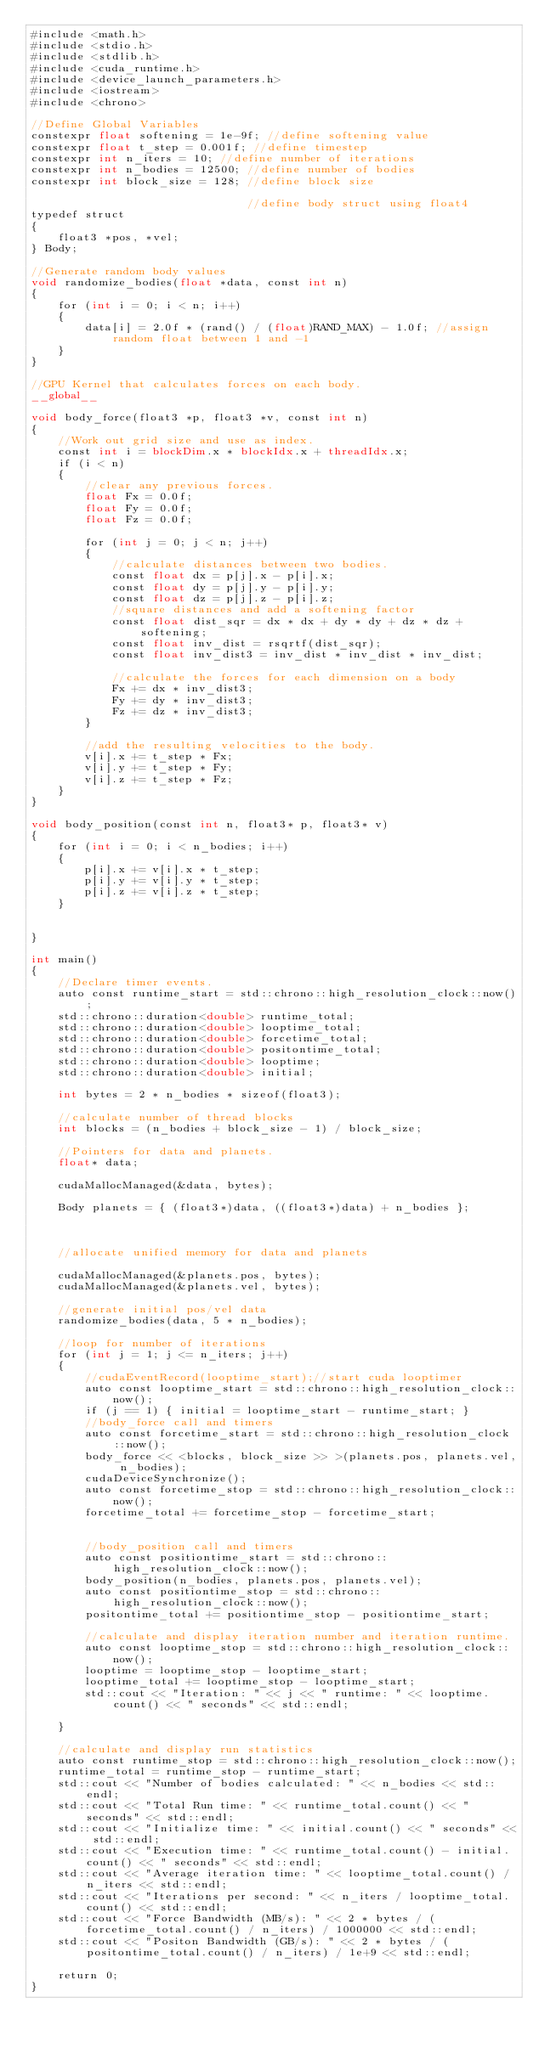Convert code to text. <code><loc_0><loc_0><loc_500><loc_500><_Cuda_>#include <math.h>
#include <stdio.h>
#include <stdlib.h>
#include <cuda_runtime.h>
#include <device_launch_parameters.h>
#include <iostream>
#include <chrono>

//Define Global Variables
constexpr float softening = 1e-9f; //define softening value
constexpr float t_step = 0.001f; //define timestep
constexpr int n_iters = 10; //define number of iterations
constexpr int n_bodies = 12500; //define number of bodies
constexpr int block_size = 128; //define block size

								//define body struct using float4
typedef struct
{
	float3 *pos, *vel;
} Body;

//Generate random body values
void randomize_bodies(float *data, const int n)
{
	for (int i = 0; i < n; i++)
	{
		data[i] = 2.0f * (rand() / (float)RAND_MAX) - 1.0f; //assign random float between 1 and -1
	}
}

//GPU Kernel that calculates forces on each body.
__global__

void body_force(float3 *p, float3 *v, const int n)
{
	//Work out grid size and use as index.
	const int i = blockDim.x * blockIdx.x + threadIdx.x;
	if (i < n)
	{
		//clear any previous forces.
		float Fx = 0.0f;
		float Fy = 0.0f;
		float Fz = 0.0f;

		for (int j = 0; j < n; j++)
		{
			//calculate distances between two bodies.
			const float dx = p[j].x - p[i].x;
			const float dy = p[j].y - p[i].y;
			const float dz = p[j].z - p[i].z;
			//square distances and add a softening factor
			const float dist_sqr = dx * dx + dy * dy + dz * dz + softening;
			const float inv_dist = rsqrtf(dist_sqr);
			const float inv_dist3 = inv_dist * inv_dist * inv_dist;

			//calculate the forces for each dimension on a body
			Fx += dx * inv_dist3;
			Fy += dy * inv_dist3;
			Fz += dz * inv_dist3;
		}

		//add the resulting velocities to the body.
		v[i].x += t_step * Fx;
		v[i].y += t_step * Fy;
		v[i].z += t_step * Fz;
	}
}

void body_position(const int n, float3* p, float3* v)
{
	for (int i = 0; i < n_bodies; i++)
	{
		p[i].x += v[i].x * t_step;
		p[i].y += v[i].y * t_step;
		p[i].z += v[i].z * t_step;
	}


}

int main()
{
	//Declare timer events.
	auto const runtime_start = std::chrono::high_resolution_clock::now();
	std::chrono::duration<double> runtime_total;
	std::chrono::duration<double> looptime_total;
	std::chrono::duration<double> forcetime_total;
	std::chrono::duration<double> positontime_total;
	std::chrono::duration<double> looptime;
	std::chrono::duration<double> initial;

	int bytes = 2 * n_bodies * sizeof(float3);

	//calculate number of thread blocks
	int blocks = (n_bodies + block_size - 1) / block_size;

	//Pointers for data and planets.
	float* data;

	cudaMallocManaged(&data, bytes);

	Body planets = { (float3*)data, ((float3*)data) + n_bodies };



	//allocate unified memory for data and planets

	cudaMallocManaged(&planets.pos, bytes);
	cudaMallocManaged(&planets.vel, bytes);

	//generate initial pos/vel data
	randomize_bodies(data, 5 * n_bodies);

	//loop for number of iterations
	for (int j = 1; j <= n_iters; j++)
	{
		//cudaEventRecord(looptime_start);//start cuda looptimer
		auto const looptime_start = std::chrono::high_resolution_clock::now();
		if (j == 1) { initial = looptime_start - runtime_start; }
		//body_force call and timers
		auto const forcetime_start = std::chrono::high_resolution_clock::now();
		body_force << <blocks, block_size >> >(planets.pos, planets.vel, n_bodies);
		cudaDeviceSynchronize();
		auto const forcetime_stop = std::chrono::high_resolution_clock::now();
		forcetime_total += forcetime_stop - forcetime_start;


		//body_position call and timers
		auto const positiontime_start = std::chrono::high_resolution_clock::now();
		body_position(n_bodies, planets.pos, planets.vel);
		auto const positiontime_stop = std::chrono::high_resolution_clock::now();
		positontime_total += positiontime_stop - positiontime_start;

		//calculate and display iteration number and iteration runtime.
		auto const looptime_stop = std::chrono::high_resolution_clock::now();
		looptime = looptime_stop - looptime_start;
		looptime_total += looptime_stop - looptime_start;
		std::cout << "Iteration: " << j << " runtime: " << looptime.count() << " seconds" << std::endl;

	}

	//calculate and display run statistics
	auto const runtime_stop = std::chrono::high_resolution_clock::now();
	runtime_total = runtime_stop - runtime_start;
	std::cout << "Number of bodies calculated: " << n_bodies << std::endl;
	std::cout << "Total Run time: " << runtime_total.count() << " seconds" << std::endl;
	std::cout << "Initialize time: " << initial.count() << " seconds" << std::endl;
	std::cout << "Execution time: " << runtime_total.count() - initial.count() << " seconds" << std::endl;
	std::cout << "Average iteration time: " << looptime_total.count() / n_iters << std::endl;
	std::cout << "Iterations per second: " << n_iters / looptime_total.count() << std::endl;
	std::cout << "Force Bandwidth (MB/s): " << 2 * bytes / (forcetime_total.count() / n_iters) / 1000000 << std::endl;
	std::cout << "Positon Bandwidth (GB/s): " << 2 * bytes / (positontime_total.count() / n_iters) / 1e+9 << std::endl;

	return 0;
}
</code> 